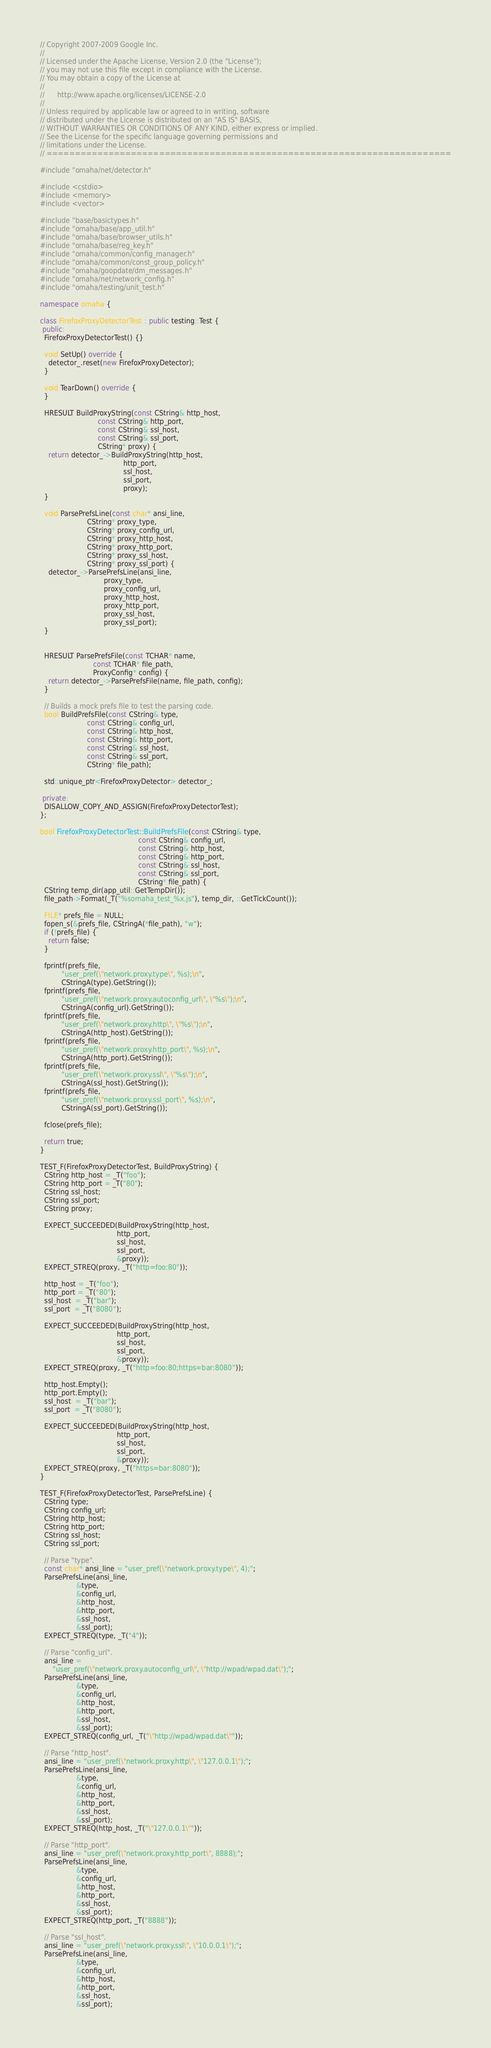Convert code to text. <code><loc_0><loc_0><loc_500><loc_500><_C++_>// Copyright 2007-2009 Google Inc.
//
// Licensed under the Apache License, Version 2.0 (the "License");
// you may not use this file except in compliance with the License.
// You may obtain a copy of the License at
//
//      http://www.apache.org/licenses/LICENSE-2.0
//
// Unless required by applicable law or agreed to in writing, software
// distributed under the License is distributed on an "AS IS" BASIS,
// WITHOUT WARRANTIES OR CONDITIONS OF ANY KIND, either express or implied.
// See the License for the specific language governing permissions and
// limitations under the License.
// ========================================================================

#include "omaha/net/detector.h"

#include <cstdio>
#include <memory>
#include <vector>

#include "base/basictypes.h"
#include "omaha/base/app_util.h"
#include "omaha/base/browser_utils.h"
#include "omaha/base/reg_key.h"
#include "omaha/common/config_manager.h"
#include "omaha/common/const_group_policy.h"
#include "omaha/goopdate/dm_messages.h"
#include "omaha/net/network_config.h"
#include "omaha/testing/unit_test.h"

namespace omaha {

class FirefoxProxyDetectorTest : public testing::Test {
 public:
  FirefoxProxyDetectorTest() {}

  void SetUp() override {
    detector_.reset(new FirefoxProxyDetector);
  }

  void TearDown() override {
  }

  HRESULT BuildProxyString(const CString& http_host,
                           const CString& http_port,
                           const CString& ssl_host,
                           const CString& ssl_port,
                           CString* proxy) {
    return detector_->BuildProxyString(http_host,
                                       http_port,
                                       ssl_host,
                                       ssl_port,
                                       proxy);
  }

  void ParsePrefsLine(const char* ansi_line,
                      CString* proxy_type,
                      CString* proxy_config_url,
                      CString* proxy_http_host,
                      CString* proxy_http_port,
                      CString* proxy_ssl_host,
                      CString* proxy_ssl_port) {
    detector_->ParsePrefsLine(ansi_line,
                              proxy_type,
                              proxy_config_url,
                              proxy_http_host,
                              proxy_http_port,
                              proxy_ssl_host,
                              proxy_ssl_port);
  }


  HRESULT ParsePrefsFile(const TCHAR* name,
                         const TCHAR* file_path,
                         ProxyConfig* config) {
    return detector_->ParsePrefsFile(name, file_path, config);
  }

  // Builds a mock prefs file to test the parsing code.
  bool BuildPrefsFile(const CString& type,
                      const CString& config_url,
                      const CString& http_host,
                      const CString& http_port,
                      const CString& ssl_host,
                      const CString& ssl_port,
                      CString* file_path);

  std::unique_ptr<FirefoxProxyDetector> detector_;

 private:
  DISALLOW_COPY_AND_ASSIGN(FirefoxProxyDetectorTest);
};

bool FirefoxProxyDetectorTest::BuildPrefsFile(const CString& type,
                                              const CString& config_url,
                                              const CString& http_host,
                                              const CString& http_port,
                                              const CString& ssl_host,
                                              const CString& ssl_port,
                                              CString* file_path) {
  CString temp_dir(app_util::GetTempDir());
  file_path->Format(_T("%somaha_test_%x.js"), temp_dir, ::GetTickCount());

  FILE* prefs_file = NULL;
  fopen_s(&prefs_file, CStringA(*file_path), "w");
  if (!prefs_file) {
    return false;
  }

  fprintf(prefs_file,
          "user_pref(\"network.proxy.type\", %s);\n",
          CStringA(type).GetString());
  fprintf(prefs_file,
          "user_pref(\"network.proxy.autoconfig_url\", \"%s\");\n",
          CStringA(config_url).GetString());
  fprintf(prefs_file,
          "user_pref(\"network.proxy.http\", \"%s\");\n",
          CStringA(http_host).GetString());
  fprintf(prefs_file,
          "user_pref(\"network.proxy.http_port\", %s);\n",
          CStringA(http_port).GetString());
  fprintf(prefs_file,
          "user_pref(\"network.proxy.ssl\", \"%s\");\n",
          CStringA(ssl_host).GetString());
  fprintf(prefs_file,
          "user_pref(\"network.proxy.ssl_port\", %s);\n",
          CStringA(ssl_port).GetString());

  fclose(prefs_file);

  return true;
}

TEST_F(FirefoxProxyDetectorTest, BuildProxyString) {
  CString http_host = _T("foo");
  CString http_port = _T("80");
  CString ssl_host;
  CString ssl_port;
  CString proxy;

  EXPECT_SUCCEEDED(BuildProxyString(http_host,
                                    http_port,
                                    ssl_host,
                                    ssl_port,
                                    &proxy));
  EXPECT_STREQ(proxy, _T("http=foo:80"));

  http_host = _T("foo");
  http_port = _T("80");
  ssl_host  = _T("bar");
  ssl_port  = _T("8080");

  EXPECT_SUCCEEDED(BuildProxyString(http_host,
                                    http_port,
                                    ssl_host,
                                    ssl_port,
                                    &proxy));
  EXPECT_STREQ(proxy, _T("http=foo:80;https=bar:8080"));

  http_host.Empty();
  http_port.Empty();
  ssl_host  = _T("bar");
  ssl_port  = _T("8080");

  EXPECT_SUCCEEDED(BuildProxyString(http_host,
                                    http_port,
                                    ssl_host,
                                    ssl_port,
                                    &proxy));
  EXPECT_STREQ(proxy, _T("https=bar:8080"));
}

TEST_F(FirefoxProxyDetectorTest, ParsePrefsLine) {
  CString type;
  CString config_url;
  CString http_host;
  CString http_port;
  CString ssl_host;
  CString ssl_port;

  // Parse "type".
  const char* ansi_line = "user_pref(\"network.proxy.type\", 4);";
  ParsePrefsLine(ansi_line,
                 &type,
                 &config_url,
                 &http_host,
                 &http_port,
                 &ssl_host,
                 &ssl_port);
  EXPECT_STREQ(type, _T("4"));

  // Parse "config_url".
  ansi_line =
      "user_pref(\"network.proxy.autoconfig_url\", \"http://wpad/wpad.dat\");";
  ParsePrefsLine(ansi_line,
                 &type,
                 &config_url,
                 &http_host,
                 &http_port,
                 &ssl_host,
                 &ssl_port);
  EXPECT_STREQ(config_url, _T("\"http://wpad/wpad.dat\""));

  // Parse "http_host".
  ansi_line = "user_pref(\"network.proxy.http\", \"127.0.0.1\");";
  ParsePrefsLine(ansi_line,
                 &type,
                 &config_url,
                 &http_host,
                 &http_port,
                 &ssl_host,
                 &ssl_port);
  EXPECT_STREQ(http_host, _T("\"127.0.0.1\""));

  // Parse "http_port".
  ansi_line = "user_pref(\"network.proxy.http_port\", 8888);";
  ParsePrefsLine(ansi_line,
                 &type,
                 &config_url,
                 &http_host,
                 &http_port,
                 &ssl_host,
                 &ssl_port);
  EXPECT_STREQ(http_port, _T("8888"));

  // Parse "ssl_host".
  ansi_line = "user_pref(\"network.proxy.ssl\", \"10.0.0.1\");";
  ParsePrefsLine(ansi_line,
                 &type,
                 &config_url,
                 &http_host,
                 &http_port,
                 &ssl_host,
                 &ssl_port);</code> 